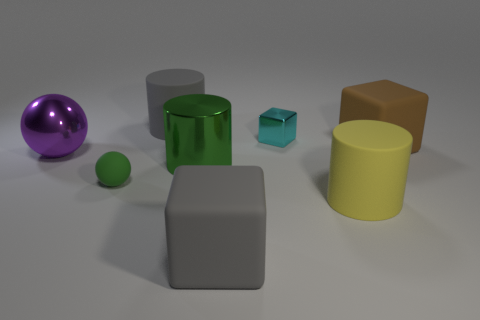What textures can you describe among the items in the image? In the image, the items display a variety of textures. The matte cube has a smooth, non-reflective surface. The green cylinder and the yellow cylinder have surfaces that appear slightly glossy, hinting at a smooth plastic-like texture. The purple sphere on the left seems to have a metallic sheen to it, suggesting a smooth and reflective metal surface. The rubber objects, which are the blue cube and small green sphere, have a matte finish indicative of a soft, rubbery texture. 